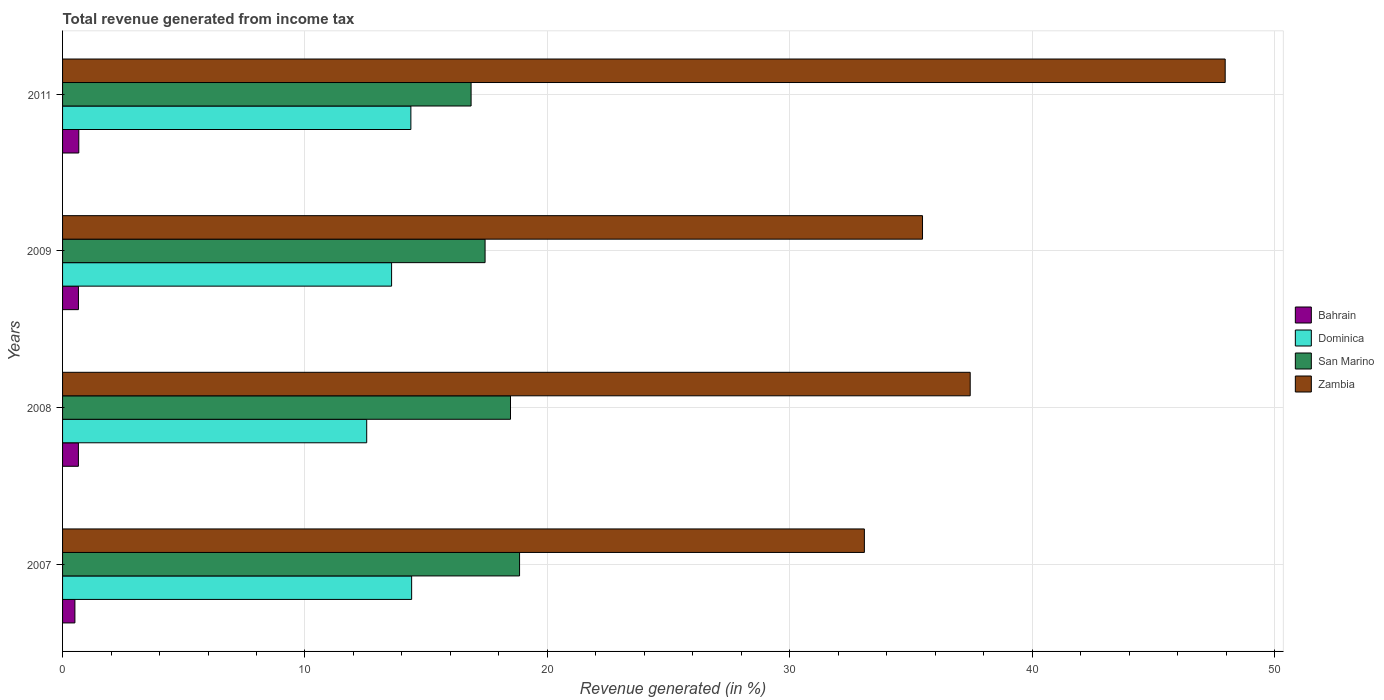How many different coloured bars are there?
Your answer should be compact. 4. How many groups of bars are there?
Keep it short and to the point. 4. What is the label of the 2nd group of bars from the top?
Your answer should be compact. 2009. In how many cases, is the number of bars for a given year not equal to the number of legend labels?
Provide a short and direct response. 0. What is the total revenue generated in San Marino in 2008?
Make the answer very short. 18.48. Across all years, what is the maximum total revenue generated in Dominica?
Give a very brief answer. 14.4. Across all years, what is the minimum total revenue generated in San Marino?
Offer a very short reply. 16.85. In which year was the total revenue generated in Bahrain maximum?
Your answer should be very brief. 2011. In which year was the total revenue generated in San Marino minimum?
Your answer should be very brief. 2011. What is the total total revenue generated in Zambia in the graph?
Your answer should be very brief. 153.97. What is the difference between the total revenue generated in Zambia in 2007 and that in 2009?
Provide a succinct answer. -2.4. What is the difference between the total revenue generated in Zambia in 2009 and the total revenue generated in San Marino in 2011?
Make the answer very short. 18.62. What is the average total revenue generated in San Marino per year?
Provide a succinct answer. 17.91. In the year 2009, what is the difference between the total revenue generated in Dominica and total revenue generated in Bahrain?
Offer a very short reply. 12.92. What is the ratio of the total revenue generated in Dominica in 2008 to that in 2011?
Ensure brevity in your answer.  0.87. Is the difference between the total revenue generated in Dominica in 2009 and 2011 greater than the difference between the total revenue generated in Bahrain in 2009 and 2011?
Offer a terse response. No. What is the difference between the highest and the second highest total revenue generated in Zambia?
Make the answer very short. 10.52. What is the difference between the highest and the lowest total revenue generated in Zambia?
Provide a succinct answer. 14.89. Is the sum of the total revenue generated in Bahrain in 2007 and 2011 greater than the maximum total revenue generated in San Marino across all years?
Make the answer very short. No. What does the 2nd bar from the top in 2008 represents?
Your answer should be compact. San Marino. What does the 4th bar from the bottom in 2008 represents?
Your answer should be very brief. Zambia. How many bars are there?
Your response must be concise. 16. Are all the bars in the graph horizontal?
Offer a terse response. Yes. How many years are there in the graph?
Ensure brevity in your answer.  4. What is the difference between two consecutive major ticks on the X-axis?
Your answer should be very brief. 10. How many legend labels are there?
Give a very brief answer. 4. What is the title of the graph?
Keep it short and to the point. Total revenue generated from income tax. Does "Fragile and conflict affected situations" appear as one of the legend labels in the graph?
Offer a very short reply. No. What is the label or title of the X-axis?
Make the answer very short. Revenue generated (in %). What is the Revenue generated (in %) of Bahrain in 2007?
Give a very brief answer. 0.51. What is the Revenue generated (in %) of Dominica in 2007?
Provide a succinct answer. 14.4. What is the Revenue generated (in %) in San Marino in 2007?
Your answer should be compact. 18.85. What is the Revenue generated (in %) of Zambia in 2007?
Your answer should be very brief. 33.08. What is the Revenue generated (in %) of Bahrain in 2008?
Ensure brevity in your answer.  0.65. What is the Revenue generated (in %) in Dominica in 2008?
Provide a short and direct response. 12.55. What is the Revenue generated (in %) in San Marino in 2008?
Your answer should be compact. 18.48. What is the Revenue generated (in %) of Zambia in 2008?
Give a very brief answer. 37.45. What is the Revenue generated (in %) of Bahrain in 2009?
Your answer should be compact. 0.65. What is the Revenue generated (in %) of Dominica in 2009?
Offer a very short reply. 13.57. What is the Revenue generated (in %) in San Marino in 2009?
Offer a terse response. 17.43. What is the Revenue generated (in %) of Zambia in 2009?
Provide a succinct answer. 35.48. What is the Revenue generated (in %) in Bahrain in 2011?
Give a very brief answer. 0.67. What is the Revenue generated (in %) of Dominica in 2011?
Offer a very short reply. 14.37. What is the Revenue generated (in %) in San Marino in 2011?
Your answer should be compact. 16.85. What is the Revenue generated (in %) in Zambia in 2011?
Your response must be concise. 47.97. Across all years, what is the maximum Revenue generated (in %) of Bahrain?
Your answer should be compact. 0.67. Across all years, what is the maximum Revenue generated (in %) in Dominica?
Your answer should be compact. 14.4. Across all years, what is the maximum Revenue generated (in %) of San Marino?
Make the answer very short. 18.85. Across all years, what is the maximum Revenue generated (in %) in Zambia?
Provide a short and direct response. 47.97. Across all years, what is the minimum Revenue generated (in %) of Bahrain?
Keep it short and to the point. 0.51. Across all years, what is the minimum Revenue generated (in %) in Dominica?
Give a very brief answer. 12.55. Across all years, what is the minimum Revenue generated (in %) of San Marino?
Ensure brevity in your answer.  16.85. Across all years, what is the minimum Revenue generated (in %) in Zambia?
Ensure brevity in your answer.  33.08. What is the total Revenue generated (in %) of Bahrain in the graph?
Your answer should be very brief. 2.49. What is the total Revenue generated (in %) of Dominica in the graph?
Your answer should be compact. 54.89. What is the total Revenue generated (in %) of San Marino in the graph?
Your answer should be very brief. 71.62. What is the total Revenue generated (in %) of Zambia in the graph?
Give a very brief answer. 153.97. What is the difference between the Revenue generated (in %) of Bahrain in 2007 and that in 2008?
Your response must be concise. -0.14. What is the difference between the Revenue generated (in %) in Dominica in 2007 and that in 2008?
Provide a short and direct response. 1.85. What is the difference between the Revenue generated (in %) of San Marino in 2007 and that in 2008?
Your answer should be very brief. 0.37. What is the difference between the Revenue generated (in %) in Zambia in 2007 and that in 2008?
Provide a succinct answer. -4.37. What is the difference between the Revenue generated (in %) in Bahrain in 2007 and that in 2009?
Offer a terse response. -0.15. What is the difference between the Revenue generated (in %) in Dominica in 2007 and that in 2009?
Your answer should be compact. 0.83. What is the difference between the Revenue generated (in %) of San Marino in 2007 and that in 2009?
Keep it short and to the point. 1.42. What is the difference between the Revenue generated (in %) in Zambia in 2007 and that in 2009?
Offer a very short reply. -2.4. What is the difference between the Revenue generated (in %) in Bahrain in 2007 and that in 2011?
Offer a very short reply. -0.16. What is the difference between the Revenue generated (in %) in Dominica in 2007 and that in 2011?
Your answer should be compact. 0.03. What is the difference between the Revenue generated (in %) in San Marino in 2007 and that in 2011?
Your answer should be very brief. 2. What is the difference between the Revenue generated (in %) in Zambia in 2007 and that in 2011?
Offer a very short reply. -14.89. What is the difference between the Revenue generated (in %) in Bahrain in 2008 and that in 2009?
Keep it short and to the point. -0. What is the difference between the Revenue generated (in %) of Dominica in 2008 and that in 2009?
Provide a succinct answer. -1.03. What is the difference between the Revenue generated (in %) of San Marino in 2008 and that in 2009?
Give a very brief answer. 1.05. What is the difference between the Revenue generated (in %) of Zambia in 2008 and that in 2009?
Your answer should be compact. 1.97. What is the difference between the Revenue generated (in %) in Bahrain in 2008 and that in 2011?
Provide a short and direct response. -0.02. What is the difference between the Revenue generated (in %) of Dominica in 2008 and that in 2011?
Give a very brief answer. -1.82. What is the difference between the Revenue generated (in %) in San Marino in 2008 and that in 2011?
Ensure brevity in your answer.  1.63. What is the difference between the Revenue generated (in %) of Zambia in 2008 and that in 2011?
Your response must be concise. -10.52. What is the difference between the Revenue generated (in %) in Bahrain in 2009 and that in 2011?
Provide a succinct answer. -0.02. What is the difference between the Revenue generated (in %) of Dominica in 2009 and that in 2011?
Your response must be concise. -0.8. What is the difference between the Revenue generated (in %) in San Marino in 2009 and that in 2011?
Provide a succinct answer. 0.58. What is the difference between the Revenue generated (in %) in Zambia in 2009 and that in 2011?
Make the answer very short. -12.49. What is the difference between the Revenue generated (in %) of Bahrain in 2007 and the Revenue generated (in %) of Dominica in 2008?
Keep it short and to the point. -12.04. What is the difference between the Revenue generated (in %) of Bahrain in 2007 and the Revenue generated (in %) of San Marino in 2008?
Your response must be concise. -17.97. What is the difference between the Revenue generated (in %) of Bahrain in 2007 and the Revenue generated (in %) of Zambia in 2008?
Your answer should be compact. -36.94. What is the difference between the Revenue generated (in %) of Dominica in 2007 and the Revenue generated (in %) of San Marino in 2008?
Offer a terse response. -4.08. What is the difference between the Revenue generated (in %) in Dominica in 2007 and the Revenue generated (in %) in Zambia in 2008?
Ensure brevity in your answer.  -23.04. What is the difference between the Revenue generated (in %) of San Marino in 2007 and the Revenue generated (in %) of Zambia in 2008?
Provide a succinct answer. -18.59. What is the difference between the Revenue generated (in %) of Bahrain in 2007 and the Revenue generated (in %) of Dominica in 2009?
Give a very brief answer. -13.07. What is the difference between the Revenue generated (in %) of Bahrain in 2007 and the Revenue generated (in %) of San Marino in 2009?
Your answer should be compact. -16.92. What is the difference between the Revenue generated (in %) of Bahrain in 2007 and the Revenue generated (in %) of Zambia in 2009?
Your answer should be compact. -34.97. What is the difference between the Revenue generated (in %) of Dominica in 2007 and the Revenue generated (in %) of San Marino in 2009?
Offer a very short reply. -3.03. What is the difference between the Revenue generated (in %) of Dominica in 2007 and the Revenue generated (in %) of Zambia in 2009?
Offer a terse response. -21.08. What is the difference between the Revenue generated (in %) of San Marino in 2007 and the Revenue generated (in %) of Zambia in 2009?
Your answer should be compact. -16.62. What is the difference between the Revenue generated (in %) of Bahrain in 2007 and the Revenue generated (in %) of Dominica in 2011?
Make the answer very short. -13.86. What is the difference between the Revenue generated (in %) of Bahrain in 2007 and the Revenue generated (in %) of San Marino in 2011?
Provide a short and direct response. -16.35. What is the difference between the Revenue generated (in %) in Bahrain in 2007 and the Revenue generated (in %) in Zambia in 2011?
Keep it short and to the point. -47.46. What is the difference between the Revenue generated (in %) of Dominica in 2007 and the Revenue generated (in %) of San Marino in 2011?
Give a very brief answer. -2.45. What is the difference between the Revenue generated (in %) in Dominica in 2007 and the Revenue generated (in %) in Zambia in 2011?
Your answer should be very brief. -33.56. What is the difference between the Revenue generated (in %) in San Marino in 2007 and the Revenue generated (in %) in Zambia in 2011?
Offer a very short reply. -29.11. What is the difference between the Revenue generated (in %) in Bahrain in 2008 and the Revenue generated (in %) in Dominica in 2009?
Give a very brief answer. -12.92. What is the difference between the Revenue generated (in %) in Bahrain in 2008 and the Revenue generated (in %) in San Marino in 2009?
Your answer should be compact. -16.78. What is the difference between the Revenue generated (in %) of Bahrain in 2008 and the Revenue generated (in %) of Zambia in 2009?
Keep it short and to the point. -34.83. What is the difference between the Revenue generated (in %) of Dominica in 2008 and the Revenue generated (in %) of San Marino in 2009?
Your answer should be very brief. -4.88. What is the difference between the Revenue generated (in %) in Dominica in 2008 and the Revenue generated (in %) in Zambia in 2009?
Your response must be concise. -22.93. What is the difference between the Revenue generated (in %) in San Marino in 2008 and the Revenue generated (in %) in Zambia in 2009?
Give a very brief answer. -17. What is the difference between the Revenue generated (in %) in Bahrain in 2008 and the Revenue generated (in %) in Dominica in 2011?
Your response must be concise. -13.72. What is the difference between the Revenue generated (in %) of Bahrain in 2008 and the Revenue generated (in %) of San Marino in 2011?
Your response must be concise. -16.2. What is the difference between the Revenue generated (in %) of Bahrain in 2008 and the Revenue generated (in %) of Zambia in 2011?
Ensure brevity in your answer.  -47.31. What is the difference between the Revenue generated (in %) of Dominica in 2008 and the Revenue generated (in %) of San Marino in 2011?
Provide a short and direct response. -4.31. What is the difference between the Revenue generated (in %) of Dominica in 2008 and the Revenue generated (in %) of Zambia in 2011?
Provide a succinct answer. -35.42. What is the difference between the Revenue generated (in %) in San Marino in 2008 and the Revenue generated (in %) in Zambia in 2011?
Give a very brief answer. -29.49. What is the difference between the Revenue generated (in %) of Bahrain in 2009 and the Revenue generated (in %) of Dominica in 2011?
Your answer should be compact. -13.72. What is the difference between the Revenue generated (in %) of Bahrain in 2009 and the Revenue generated (in %) of San Marino in 2011?
Your answer should be very brief. -16.2. What is the difference between the Revenue generated (in %) of Bahrain in 2009 and the Revenue generated (in %) of Zambia in 2011?
Your response must be concise. -47.31. What is the difference between the Revenue generated (in %) in Dominica in 2009 and the Revenue generated (in %) in San Marino in 2011?
Offer a terse response. -3.28. What is the difference between the Revenue generated (in %) of Dominica in 2009 and the Revenue generated (in %) of Zambia in 2011?
Provide a succinct answer. -34.39. What is the difference between the Revenue generated (in %) of San Marino in 2009 and the Revenue generated (in %) of Zambia in 2011?
Ensure brevity in your answer.  -30.53. What is the average Revenue generated (in %) in Bahrain per year?
Keep it short and to the point. 0.62. What is the average Revenue generated (in %) of Dominica per year?
Offer a very short reply. 13.72. What is the average Revenue generated (in %) in San Marino per year?
Keep it short and to the point. 17.91. What is the average Revenue generated (in %) in Zambia per year?
Provide a succinct answer. 38.49. In the year 2007, what is the difference between the Revenue generated (in %) in Bahrain and Revenue generated (in %) in Dominica?
Your answer should be very brief. -13.89. In the year 2007, what is the difference between the Revenue generated (in %) in Bahrain and Revenue generated (in %) in San Marino?
Provide a short and direct response. -18.35. In the year 2007, what is the difference between the Revenue generated (in %) in Bahrain and Revenue generated (in %) in Zambia?
Your answer should be very brief. -32.57. In the year 2007, what is the difference between the Revenue generated (in %) in Dominica and Revenue generated (in %) in San Marino?
Give a very brief answer. -4.45. In the year 2007, what is the difference between the Revenue generated (in %) in Dominica and Revenue generated (in %) in Zambia?
Provide a short and direct response. -18.68. In the year 2007, what is the difference between the Revenue generated (in %) of San Marino and Revenue generated (in %) of Zambia?
Keep it short and to the point. -14.23. In the year 2008, what is the difference between the Revenue generated (in %) in Bahrain and Revenue generated (in %) in Dominica?
Keep it short and to the point. -11.89. In the year 2008, what is the difference between the Revenue generated (in %) in Bahrain and Revenue generated (in %) in San Marino?
Your answer should be very brief. -17.83. In the year 2008, what is the difference between the Revenue generated (in %) of Bahrain and Revenue generated (in %) of Zambia?
Provide a short and direct response. -36.79. In the year 2008, what is the difference between the Revenue generated (in %) in Dominica and Revenue generated (in %) in San Marino?
Offer a terse response. -5.93. In the year 2008, what is the difference between the Revenue generated (in %) in Dominica and Revenue generated (in %) in Zambia?
Your answer should be very brief. -24.9. In the year 2008, what is the difference between the Revenue generated (in %) in San Marino and Revenue generated (in %) in Zambia?
Offer a very short reply. -18.97. In the year 2009, what is the difference between the Revenue generated (in %) of Bahrain and Revenue generated (in %) of Dominica?
Offer a terse response. -12.92. In the year 2009, what is the difference between the Revenue generated (in %) of Bahrain and Revenue generated (in %) of San Marino?
Provide a succinct answer. -16.78. In the year 2009, what is the difference between the Revenue generated (in %) of Bahrain and Revenue generated (in %) of Zambia?
Make the answer very short. -34.82. In the year 2009, what is the difference between the Revenue generated (in %) of Dominica and Revenue generated (in %) of San Marino?
Keep it short and to the point. -3.86. In the year 2009, what is the difference between the Revenue generated (in %) of Dominica and Revenue generated (in %) of Zambia?
Keep it short and to the point. -21.9. In the year 2009, what is the difference between the Revenue generated (in %) in San Marino and Revenue generated (in %) in Zambia?
Ensure brevity in your answer.  -18.05. In the year 2011, what is the difference between the Revenue generated (in %) of Bahrain and Revenue generated (in %) of Dominica?
Provide a succinct answer. -13.7. In the year 2011, what is the difference between the Revenue generated (in %) in Bahrain and Revenue generated (in %) in San Marino?
Offer a very short reply. -16.18. In the year 2011, what is the difference between the Revenue generated (in %) in Bahrain and Revenue generated (in %) in Zambia?
Ensure brevity in your answer.  -47.3. In the year 2011, what is the difference between the Revenue generated (in %) of Dominica and Revenue generated (in %) of San Marino?
Ensure brevity in your answer.  -2.48. In the year 2011, what is the difference between the Revenue generated (in %) in Dominica and Revenue generated (in %) in Zambia?
Your answer should be very brief. -33.6. In the year 2011, what is the difference between the Revenue generated (in %) of San Marino and Revenue generated (in %) of Zambia?
Keep it short and to the point. -31.11. What is the ratio of the Revenue generated (in %) in Bahrain in 2007 to that in 2008?
Provide a short and direct response. 0.78. What is the ratio of the Revenue generated (in %) of Dominica in 2007 to that in 2008?
Your response must be concise. 1.15. What is the ratio of the Revenue generated (in %) in San Marino in 2007 to that in 2008?
Offer a very short reply. 1.02. What is the ratio of the Revenue generated (in %) in Zambia in 2007 to that in 2008?
Offer a very short reply. 0.88. What is the ratio of the Revenue generated (in %) of Bahrain in 2007 to that in 2009?
Provide a short and direct response. 0.78. What is the ratio of the Revenue generated (in %) of Dominica in 2007 to that in 2009?
Your answer should be compact. 1.06. What is the ratio of the Revenue generated (in %) of San Marino in 2007 to that in 2009?
Your answer should be very brief. 1.08. What is the ratio of the Revenue generated (in %) of Zambia in 2007 to that in 2009?
Your answer should be very brief. 0.93. What is the ratio of the Revenue generated (in %) in Bahrain in 2007 to that in 2011?
Provide a succinct answer. 0.76. What is the ratio of the Revenue generated (in %) in San Marino in 2007 to that in 2011?
Your response must be concise. 1.12. What is the ratio of the Revenue generated (in %) in Zambia in 2007 to that in 2011?
Your answer should be very brief. 0.69. What is the ratio of the Revenue generated (in %) of Dominica in 2008 to that in 2009?
Offer a very short reply. 0.92. What is the ratio of the Revenue generated (in %) of San Marino in 2008 to that in 2009?
Offer a very short reply. 1.06. What is the ratio of the Revenue generated (in %) of Zambia in 2008 to that in 2009?
Your answer should be compact. 1.06. What is the ratio of the Revenue generated (in %) of Bahrain in 2008 to that in 2011?
Offer a terse response. 0.98. What is the ratio of the Revenue generated (in %) in Dominica in 2008 to that in 2011?
Your answer should be very brief. 0.87. What is the ratio of the Revenue generated (in %) in San Marino in 2008 to that in 2011?
Provide a succinct answer. 1.1. What is the ratio of the Revenue generated (in %) of Zambia in 2008 to that in 2011?
Keep it short and to the point. 0.78. What is the ratio of the Revenue generated (in %) in Bahrain in 2009 to that in 2011?
Provide a succinct answer. 0.98. What is the ratio of the Revenue generated (in %) in Dominica in 2009 to that in 2011?
Your response must be concise. 0.94. What is the ratio of the Revenue generated (in %) in San Marino in 2009 to that in 2011?
Offer a terse response. 1.03. What is the ratio of the Revenue generated (in %) of Zambia in 2009 to that in 2011?
Your answer should be very brief. 0.74. What is the difference between the highest and the second highest Revenue generated (in %) of Bahrain?
Your answer should be very brief. 0.02. What is the difference between the highest and the second highest Revenue generated (in %) in Dominica?
Provide a short and direct response. 0.03. What is the difference between the highest and the second highest Revenue generated (in %) of San Marino?
Offer a terse response. 0.37. What is the difference between the highest and the second highest Revenue generated (in %) of Zambia?
Provide a short and direct response. 10.52. What is the difference between the highest and the lowest Revenue generated (in %) of Bahrain?
Offer a terse response. 0.16. What is the difference between the highest and the lowest Revenue generated (in %) in Dominica?
Make the answer very short. 1.85. What is the difference between the highest and the lowest Revenue generated (in %) in San Marino?
Give a very brief answer. 2. What is the difference between the highest and the lowest Revenue generated (in %) of Zambia?
Your response must be concise. 14.89. 